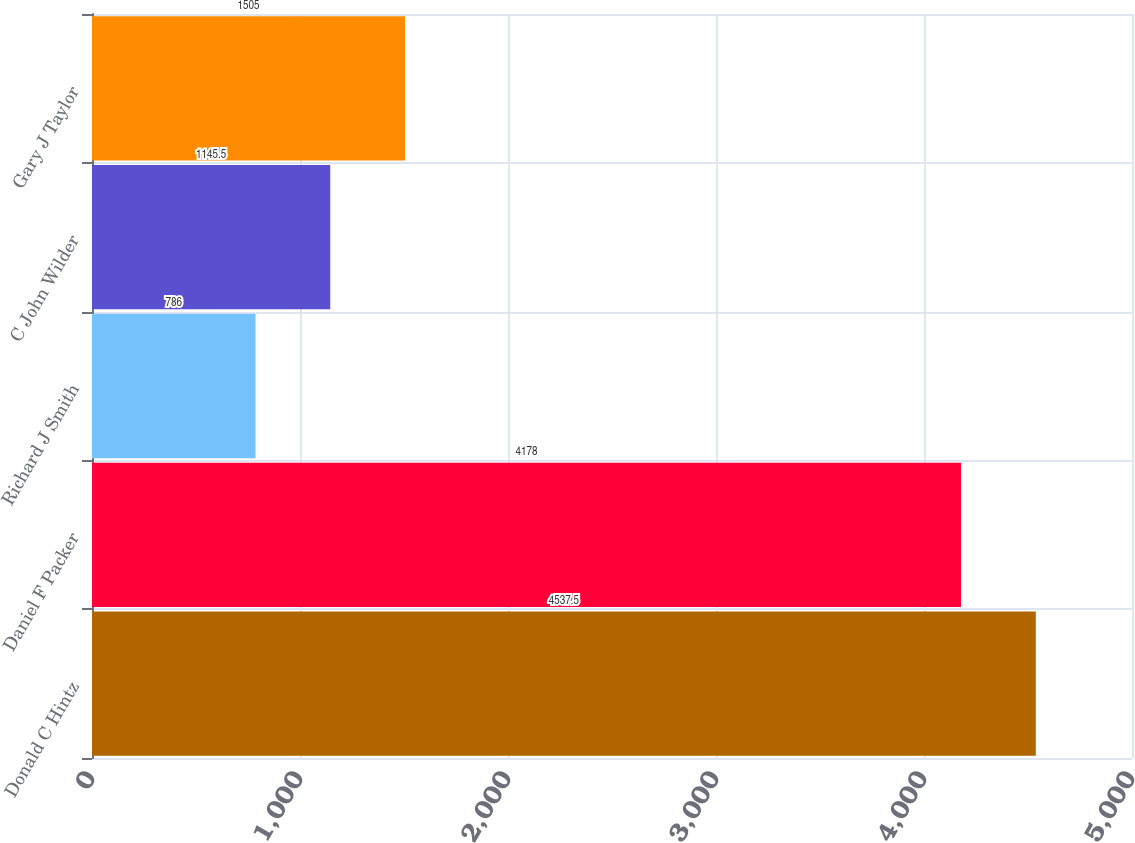<chart> <loc_0><loc_0><loc_500><loc_500><bar_chart><fcel>Donald C Hintz<fcel>Daniel F Packer<fcel>Richard J Smith<fcel>C John Wilder<fcel>Gary J Taylor<nl><fcel>4537.5<fcel>4178<fcel>786<fcel>1145.5<fcel>1505<nl></chart> 